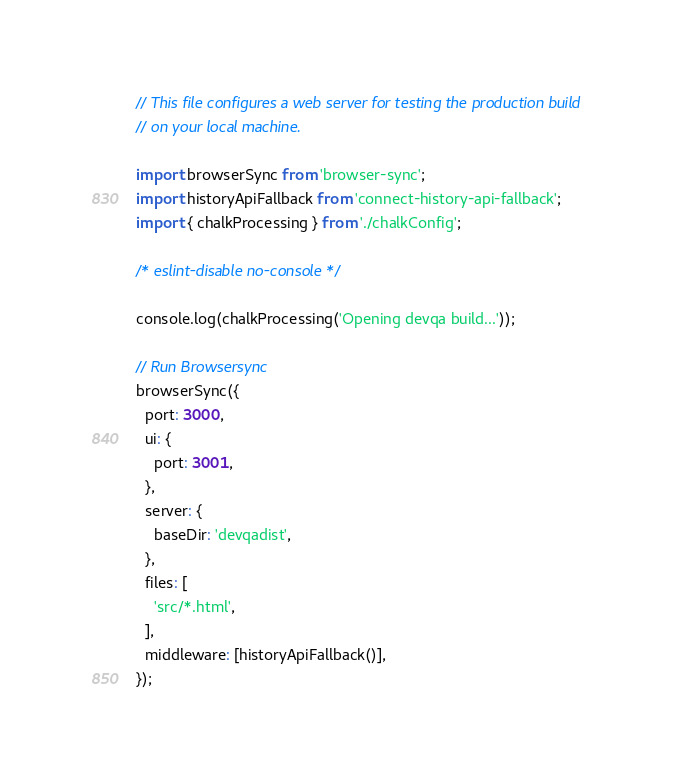<code> <loc_0><loc_0><loc_500><loc_500><_JavaScript_>// This file configures a web server for testing the production build
// on your local machine.

import browserSync from 'browser-sync';
import historyApiFallback from 'connect-history-api-fallback';
import { chalkProcessing } from './chalkConfig';

/* eslint-disable no-console */

console.log(chalkProcessing('Opening devqa build...'));

// Run Browsersync
browserSync({
  port: 3000,
  ui: {
    port: 3001,
  },
  server: {
    baseDir: 'devqadist',
  },
  files: [
    'src/*.html',
  ],
  middleware: [historyApiFallback()],
});
</code> 